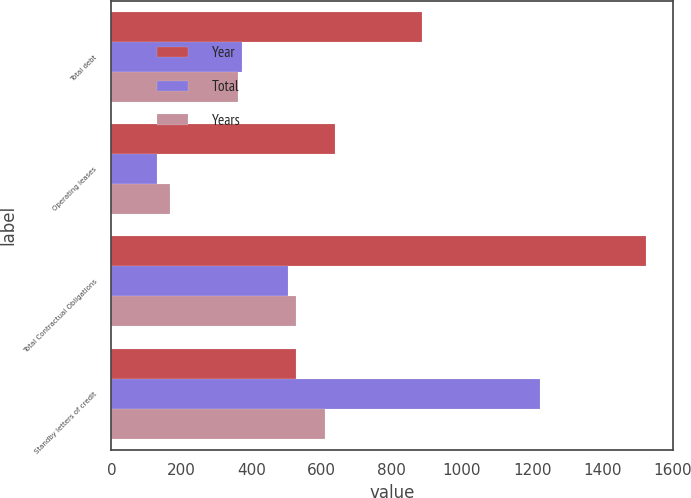<chart> <loc_0><loc_0><loc_500><loc_500><stacked_bar_chart><ecel><fcel>Total debt<fcel>Operating leases<fcel>Total Contractual Obligations<fcel>Standby letters of credit<nl><fcel>Year<fcel>887<fcel>639<fcel>1526<fcel>526<nl><fcel>Total<fcel>373<fcel>130<fcel>503<fcel>1224<nl><fcel>Years<fcel>360<fcel>166<fcel>526<fcel>609<nl></chart> 